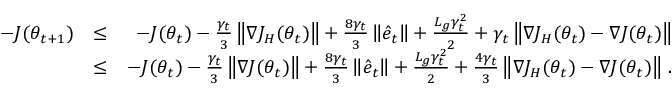Convert formula to latex. <formula><loc_0><loc_0><loc_500><loc_500>\begin{array} { r l r } { - J ( \theta _ { t + 1 } ) } & { \leq } & { - J ( \theta _ { t } ) - \frac { \gamma _ { t } } { 3 } \left \| \nabla J _ { H } ( \theta _ { t } ) \right \| + \frac { 8 \gamma _ { t } } { 3 } \left \| \hat { e } _ { t } \right \| + \frac { L _ { g } \gamma _ { t } ^ { 2 } } { 2 } + \gamma _ { t } \left \| \nabla J _ { H } ( \theta _ { t } ) - \nabla J ( \theta _ { t } ) \right \| } \\ & { \leq } & { - J ( \theta _ { t } ) - \frac { \gamma _ { t } } { 3 } \left \| \nabla J ( \theta _ { t } ) \right \| + \frac { 8 \gamma _ { t } } { 3 } \left \| \hat { e } _ { t } \right \| + \frac { L _ { g } \gamma _ { t } ^ { 2 } } { 2 } + \frac { 4 \gamma _ { t } } { 3 } \left \| \nabla J _ { H } ( \theta _ { t } ) - \nabla J ( \theta _ { t } ) \right \| \, . } \end{array}</formula> 